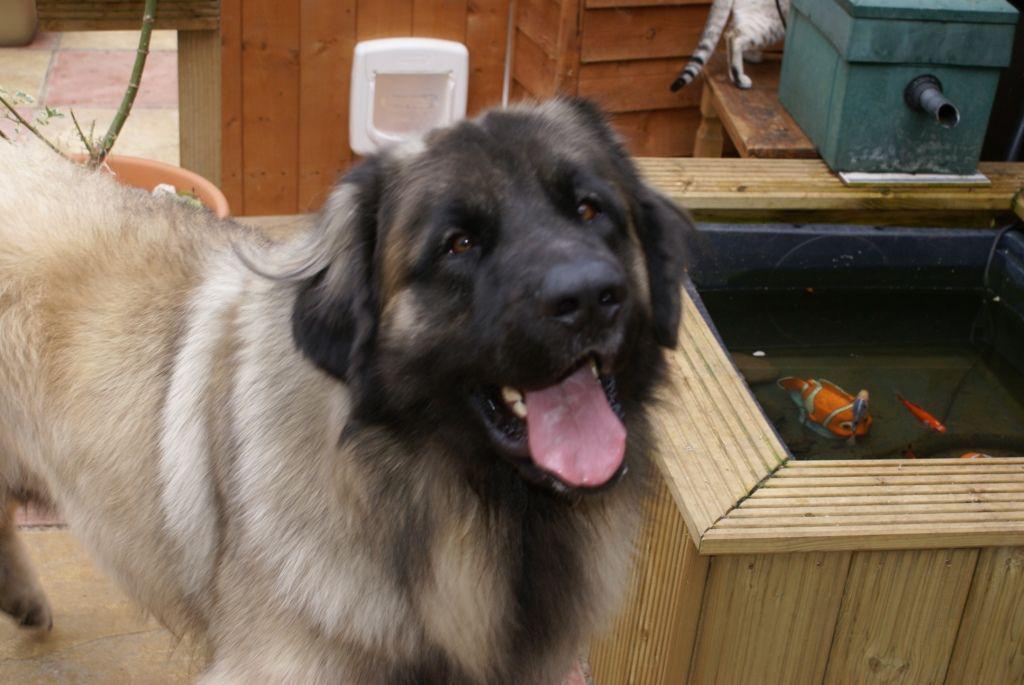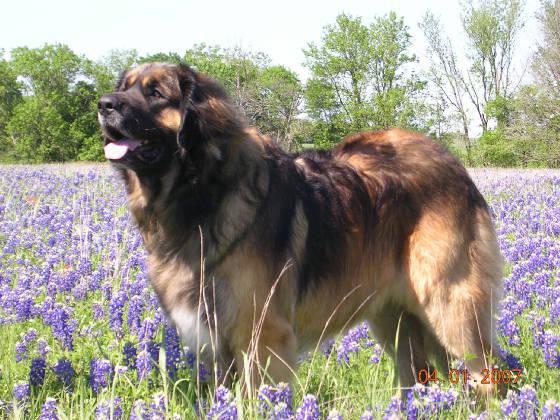The first image is the image on the left, the second image is the image on the right. Analyze the images presented: Is the assertion "There are at least three fluffy black and tan dogs." valid? Answer yes or no. No. The first image is the image on the left, the second image is the image on the right. Assess this claim about the two images: "We've got two dogs here.". Correct or not? Answer yes or no. Yes. 